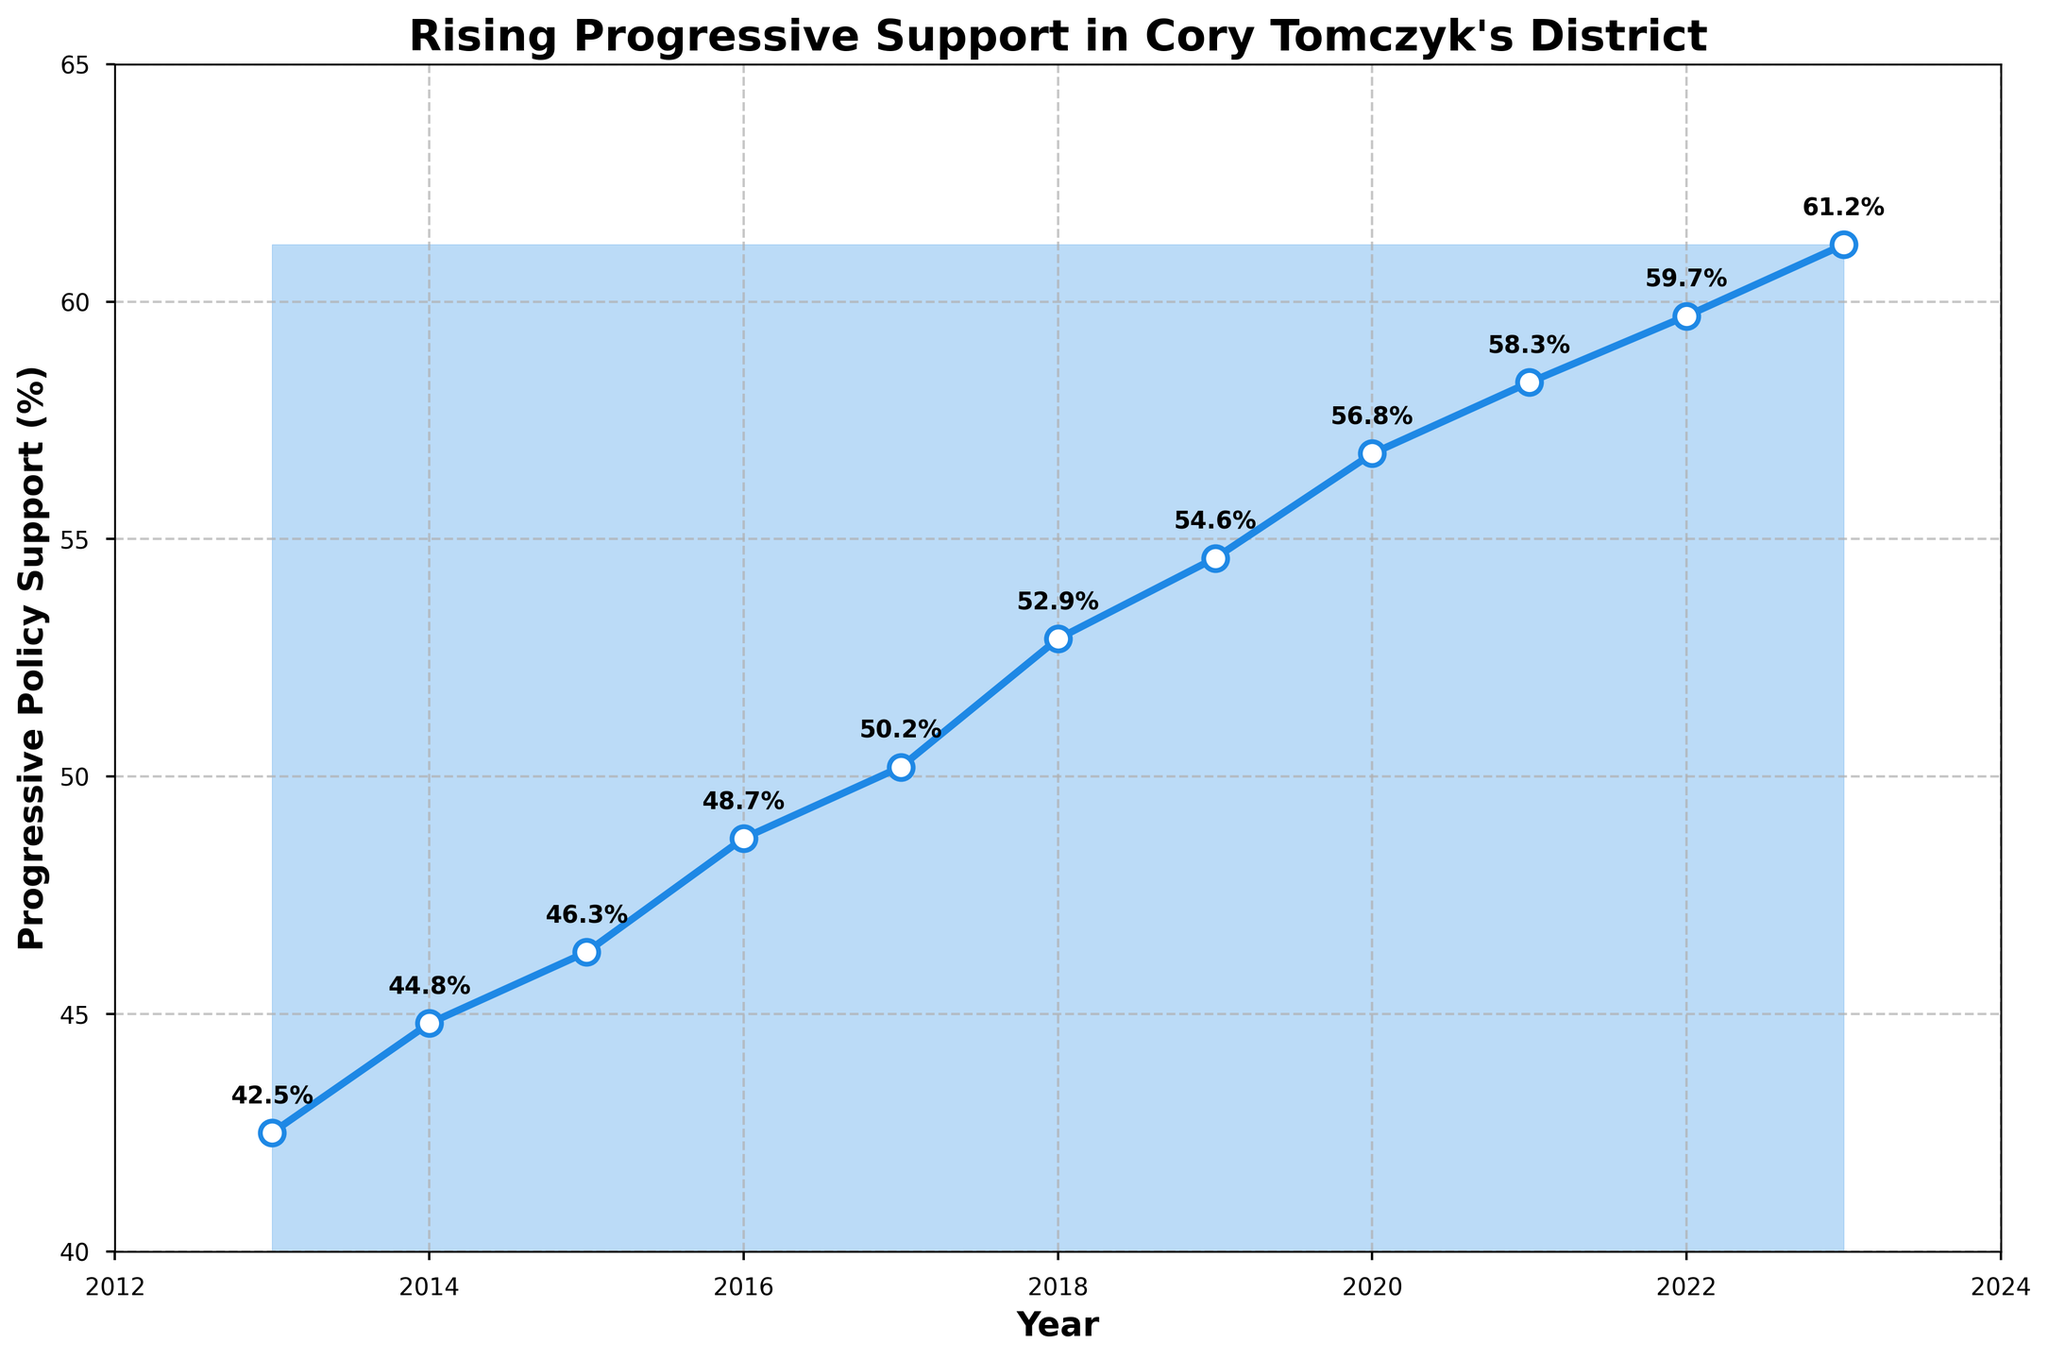What is the percentage increase in support for progressive policies from 2013 to 2023? The initial support in 2013 was 42.5%, and in 2023, it was 61.2%. The increase is 61.2 - 42.5 = 18.7%.
Answer: 18.7% What is the average support for progressive policies over the decade? Sum all the percentages and divide by the number of years: (42.5 + 44.8 + 46.3 + 48.7 + 50.2 + 52.9 + 54.6 + 56.8 + 58.3 + 59.7 + 61.2) / 11 = 53.64%.
Answer: 53.64% Between which two consecutive years was the largest increase in support? Check the difference year by year: 2014-2013 (2.3%), 2015-2014 (1.5%), 2016-2015 (2.4%), 2017-2016 (1.5%), 2018-2017 (2.7%), 2019-2018 (1.7%), 2020-2019 (2.2%), 2021-2020 (1.5%), 2022-2021 (1.4%), 2023-2022 (1.5%). The largest increase was between 2017 and 2018 (2.7%).
Answer: 2017-2018 What was the support percentage in the midpoint year 2018? Look at the data for 2018, which shows 52.9%.
Answer: 52.9% How many years did it take for the support to increase from below 50% to above 50%? Identify when support went above 50%: it increased from 48.7% in 2016 to 50.2% in 2017. Hence, it took 4 years from 2013 to 2017.
Answer: 4 years If the trend continues, what would be the estimated support percentage in 2024? Based on a linear approximation from 2022 to 2023 (1.5% increase), add this increment to 2023: 61.2 + 1.5 = 62.7%.
Answer: 62.7% How does the support in 2020 compare to the support in 2015? The support in 2020 was 56.8%, while in 2015, it was 46.3%. So, 56.8% is greater than 46.3%.
Answer: 56.8% > 46.3% Which year had the smallest increase in support compared to the previous year? Compare year-to-year increases: smallest increase occurred between 2022 and 2021 which was 1.4%.
Answer: 2021-2022 Is the trend in support for progressive policies upward or downward over the last decade? The line chart consistently shows an upward trend in support from 42.5% in 2013 to 61.2% in 2023.
Answer: Upward 